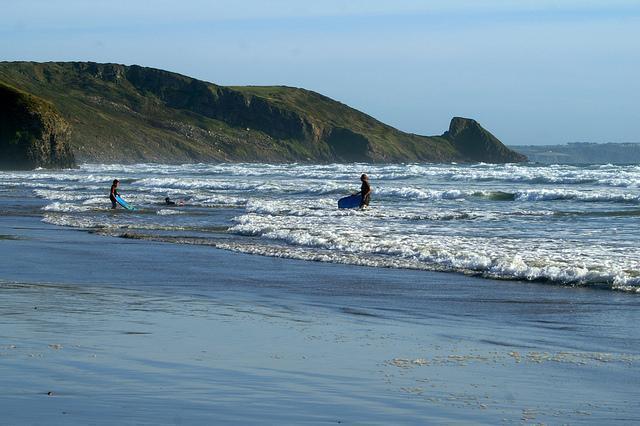What animal can usually be found here?
Pick the right solution, then justify: 'Answer: answer
Rationale: rationale.'
Options: Elk, tiger, fish, koala bear. Answer: fish.
Rationale: The beach is surrounded by water that is full of different kinds of fish. 